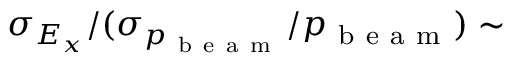Convert formula to latex. <formula><loc_0><loc_0><loc_500><loc_500>\sigma _ { E _ { x } } / ( \sigma _ { p _ { b e a m } } / p _ { b e a m } ) \sim</formula> 